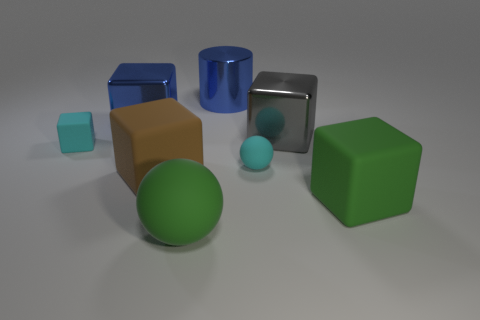Subtract all purple cylinders. Subtract all purple cubes. How many cylinders are left? 1 Add 1 tiny matte spheres. How many objects exist? 9 Subtract all cylinders. How many objects are left? 7 Add 6 cyan rubber objects. How many cyan rubber objects exist? 8 Subtract 1 green balls. How many objects are left? 7 Subtract all big gray metallic blocks. Subtract all cyan objects. How many objects are left? 5 Add 1 brown matte blocks. How many brown matte blocks are left? 2 